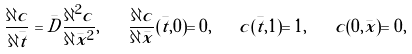Convert formula to latex. <formula><loc_0><loc_0><loc_500><loc_500>\frac { \partial c } { \partial \bar { t } } = \bar { D } \frac { \partial ^ { 2 } c } { \partial \bar { x } ^ { 2 } } , \quad \frac { \partial c } { \partial \bar { x } } ( \bar { t } , 0 ) = 0 , \quad c ( \bar { t } , 1 ) = 1 , \quad c ( 0 , \bar { x } ) = 0 ,</formula> 